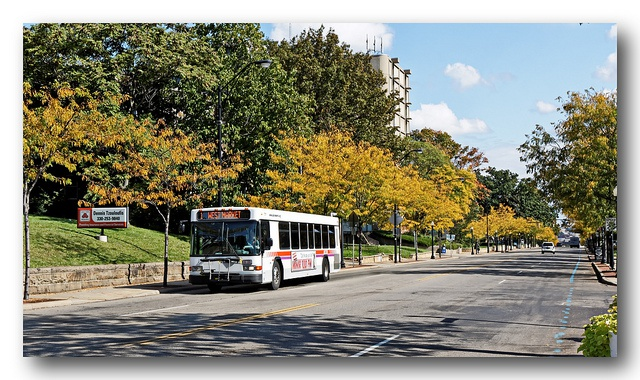Describe the objects in this image and their specific colors. I can see bus in white, black, gray, and darkgray tones, car in white, black, lightgray, gray, and darkgray tones, and car in white, black, darkblue, gray, and darkgray tones in this image. 